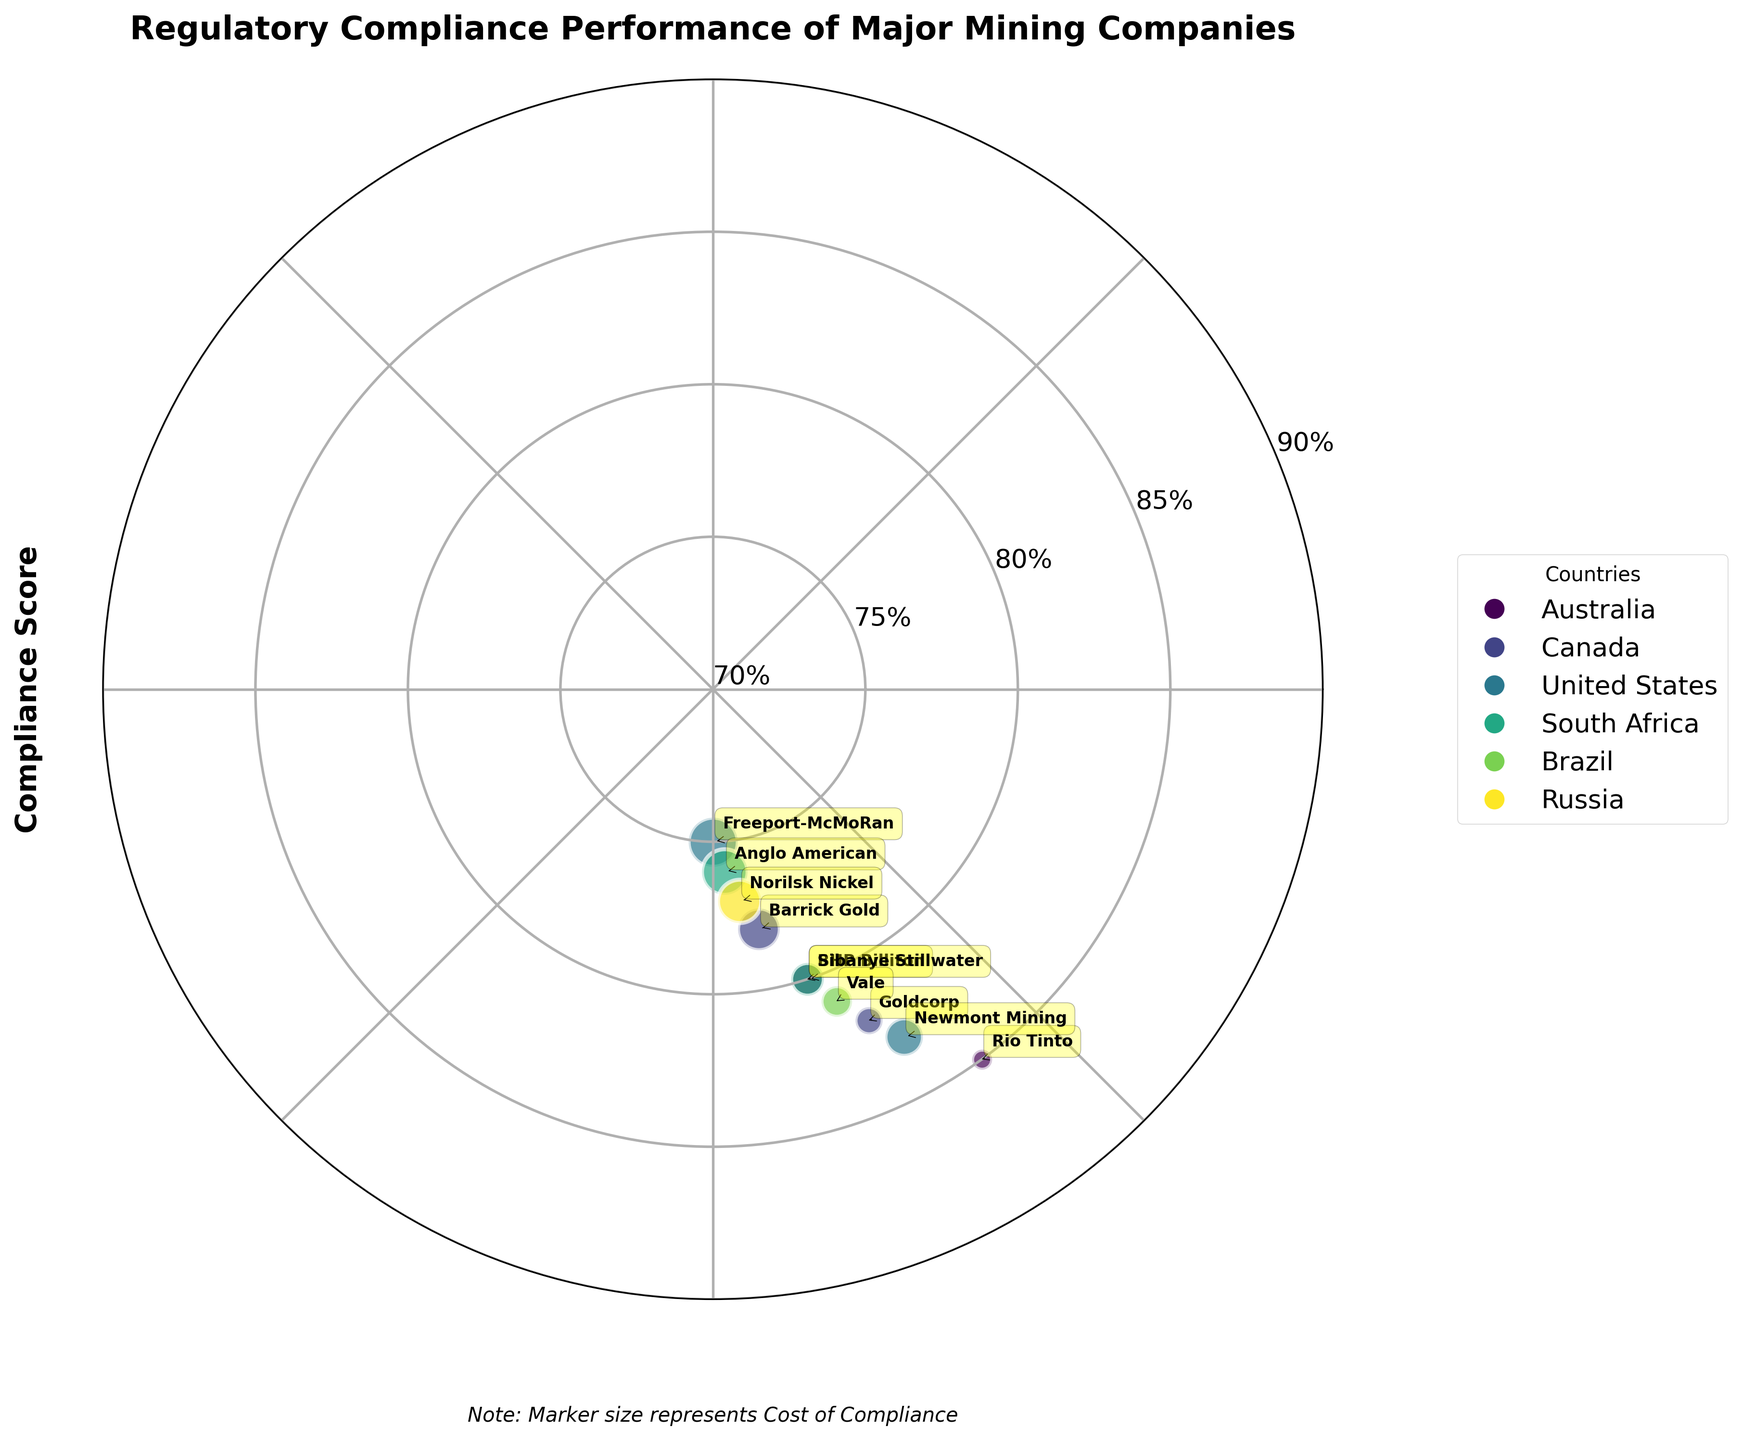How many companies are represented on the plot? By visually counting each company's label or marker on the plot, we can determine the total number of companies represented.
Answer: 10 What country has the highest compliance score and which company represents it? By observing the radial positioning of the points, the company with the highest compliance score is closest to 90 degrees on the plot. It’s Rio Tinto from Australia.
Answer: Australia, Rio Tinto What is the cost of compliance for the companies from the United States? To determine the cost of compliance, look for the sizes of the markers representing companies from the United States and refer to the provided data. Freeport-McMoRan has a cost of compliance of 140, and Newmont Mining has 125.
Answer: 140, 125 Compare the compliance scores of Barrick Gold and Goldcorp. Which one is higher and by how much? Barrick Gold has a compliance score of 78, and Goldcorp has a score of 82. Subtracting 78 from 82 gives the difference.
Answer: Goldcorp by 4 Which countries are represented on the plot, and how many companies from each country are there? By checking the legend for colors representing countries and counting the markers within each color, determine the list of countries and count the companies.
Answer: Australia (2), Canada (2), United States (2), South Africa (2), Brazil (1), Russia (1) What is the average compliance score of companies from Canada? The compliance scores for Canadian companies (Barrick Gold and Goldcorp) are 78 and 82. Adding these and dividing by 2 gives the average.
Answer: 80 Is there any correlation between the size of the markers and the compliance scores? By visually assessing the plot, look for a pattern where larger or smaller markers tend to cluster around specific compliance scores. The pattern appears to be random with no clear correlation.
Answer: No clear correlation Which company has the largest marker and what does that represent? The largest marker represents the company with the highest cost of compliance, which can be identified by relative size among all markers. Freeport-McMoRan has the largest marker.
Answer: Freeport-McMoRan How do the compliance scores of South African companies compare? Both South African companies, Anglo American and Sibanye Stillwater, have scores of 76 and 80, respectively. Comparing these shows Sibanye Stillwater has a higher score.
Answer: Sibanye Stillwater Which company in Brazil has a higher compliance score and how high is it? Identify the marker representing Brazil and check the radial position for compliance score. Vale has a score of 81.
Answer: Vale, 81 